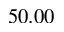<formula> <loc_0><loc_0><loc_500><loc_500>5 0 . 0 0</formula> 